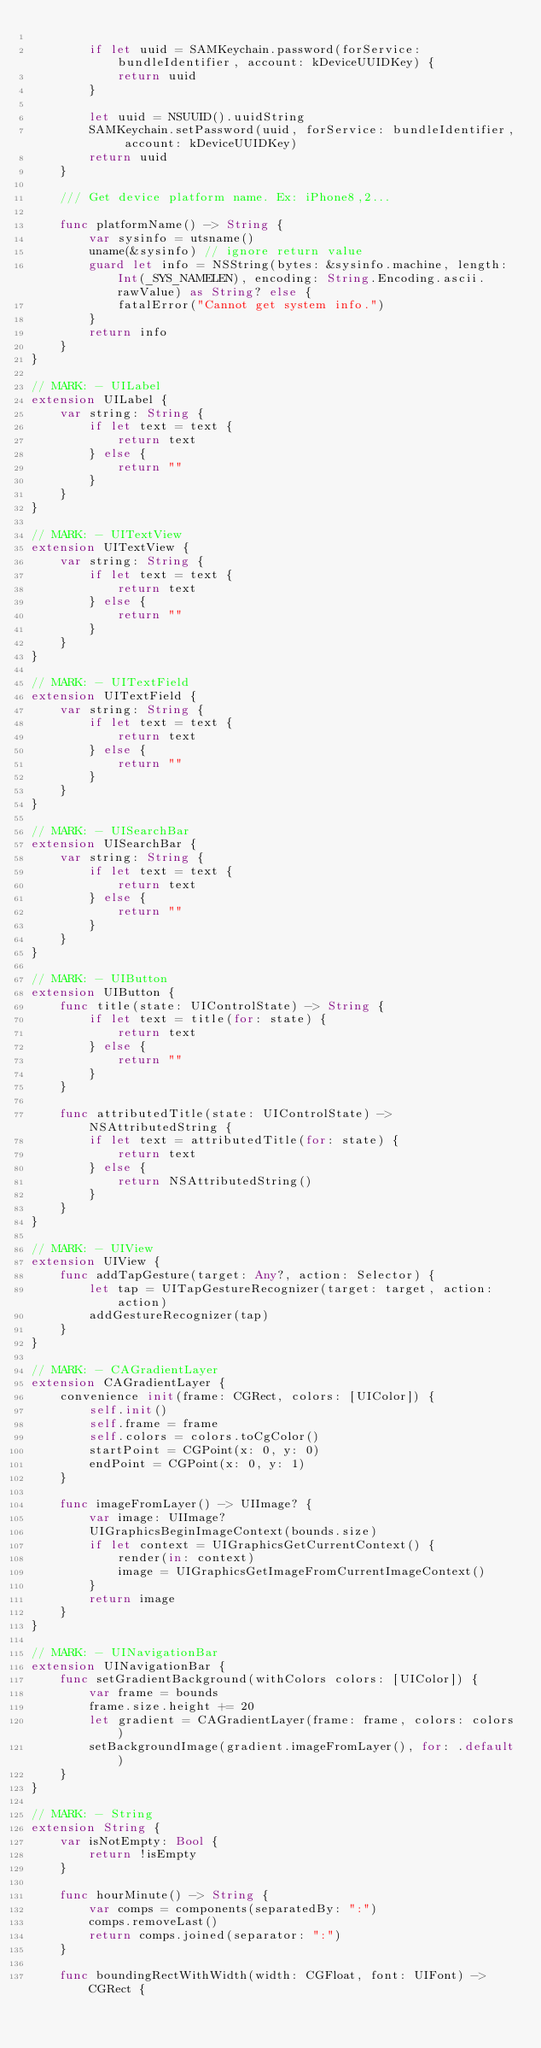<code> <loc_0><loc_0><loc_500><loc_500><_Swift_>
        if let uuid = SAMKeychain.password(forService: bundleIdentifier, account: kDeviceUUIDKey) {
            return uuid
        }

        let uuid = NSUUID().uuidString
        SAMKeychain.setPassword(uuid, forService: bundleIdentifier, account: kDeviceUUIDKey)
        return uuid
    }

    /// Get device platform name. Ex: iPhone8,2...
    
    func platformName() -> String {
        var sysinfo = utsname()
        uname(&sysinfo) // ignore return value
        guard let info = NSString(bytes: &sysinfo.machine, length: Int(_SYS_NAMELEN), encoding: String.Encoding.ascii.rawValue) as String? else {
            fatalError("Cannot get system info.")
        }
        return info
    }
}

// MARK: - UILabel
extension UILabel {
    var string: String {
        if let text = text {
            return text
        } else {
            return ""
        }
    }
}

// MARK: - UITextView
extension UITextView {
    var string: String {
        if let text = text {
            return text
        } else {
            return ""
        }
    }
}

// MARK: - UITextField
extension UITextField {
    var string: String {
        if let text = text {
            return text
        } else {
            return ""
        }
    }
}

// MARK: - UISearchBar
extension UISearchBar {
    var string: String {
        if let text = text {
            return text
        } else {
            return ""
        }
    }
}

// MARK: - UIButton
extension UIButton {
    func title(state: UIControlState) -> String {
        if let text = title(for: state) {
            return text
        } else {
            return ""
        }
    }

    func attributedTitle(state: UIControlState) -> NSAttributedString {
        if let text = attributedTitle(for: state) {
            return text
        } else {
            return NSAttributedString()
        }
    }
}

// MARK: - UIView
extension UIView {
    func addTapGesture(target: Any?, action: Selector) {
        let tap = UITapGestureRecognizer(target: target, action: action)
        addGestureRecognizer(tap)
    }
}

// MARK: - CAGradientLayer
extension CAGradientLayer {
    convenience init(frame: CGRect, colors: [UIColor]) {
        self.init()
        self.frame = frame
        self.colors = colors.toCgColor()
        startPoint = CGPoint(x: 0, y: 0)
        endPoint = CGPoint(x: 0, y: 1)
    }

    func imageFromLayer() -> UIImage? {
        var image: UIImage?
        UIGraphicsBeginImageContext(bounds.size)
        if let context = UIGraphicsGetCurrentContext() {
            render(in: context)
            image = UIGraphicsGetImageFromCurrentImageContext()
        }
        return image
    }
}

// MARK: - UINavigationBar
extension UINavigationBar {
    func setGradientBackground(withColors colors: [UIColor]) {
        var frame = bounds
        frame.size.height += 20
        let gradient = CAGradientLayer(frame: frame, colors: colors)
        setBackgroundImage(gradient.imageFromLayer(), for: .default)
    }
}

// MARK: - String
extension String {
    var isNotEmpty: Bool {
        return !isEmpty
    }

    func hourMinute() -> String {
        var comps = components(separatedBy: ":")
        comps.removeLast()
        return comps.joined(separator: ":")
    }

    func boundingRectWithWidth(width: CGFloat, font: UIFont) -> CGRect {</code> 